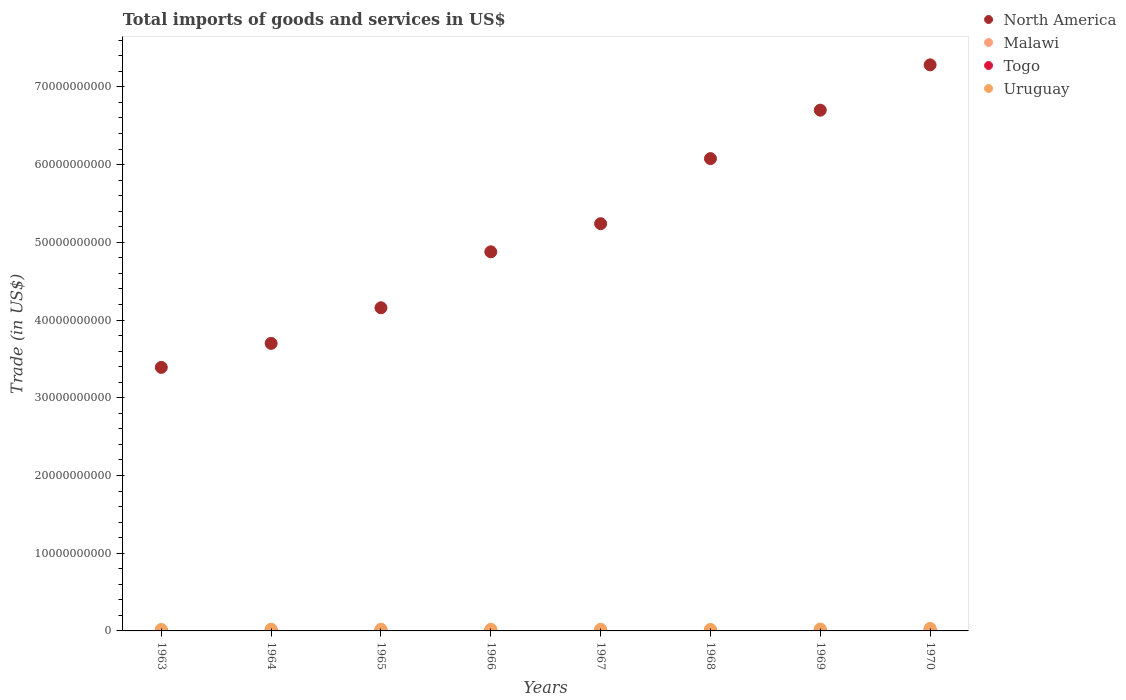How many different coloured dotlines are there?
Ensure brevity in your answer.  4. Is the number of dotlines equal to the number of legend labels?
Your answer should be compact. Yes. What is the total imports of goods and services in Malawi in 1963?
Offer a terse response. 7.15e+07. Across all years, what is the maximum total imports of goods and services in Togo?
Provide a succinct answer. 9.85e+07. Across all years, what is the minimum total imports of goods and services in Togo?
Ensure brevity in your answer.  4.27e+07. In which year was the total imports of goods and services in Togo minimum?
Offer a terse response. 1963. What is the total total imports of goods and services in Togo in the graph?
Provide a short and direct response. 5.47e+08. What is the difference between the total imports of goods and services in North America in 1964 and that in 1969?
Your response must be concise. -3.00e+1. What is the difference between the total imports of goods and services in Malawi in 1967 and the total imports of goods and services in Togo in 1970?
Keep it short and to the point. -4.34e+06. What is the average total imports of goods and services in Uruguay per year?
Give a very brief answer. 2.26e+08. In the year 1965, what is the difference between the total imports of goods and services in Uruguay and total imports of goods and services in North America?
Offer a terse response. -4.14e+1. In how many years, is the total imports of goods and services in Uruguay greater than 56000000000 US$?
Keep it short and to the point. 0. What is the ratio of the total imports of goods and services in Uruguay in 1964 to that in 1966?
Provide a short and direct response. 1.08. Is the difference between the total imports of goods and services in Uruguay in 1964 and 1969 greater than the difference between the total imports of goods and services in North America in 1964 and 1969?
Ensure brevity in your answer.  Yes. What is the difference between the highest and the second highest total imports of goods and services in Uruguay?
Provide a succinct answer. 8.19e+07. What is the difference between the highest and the lowest total imports of goods and services in Uruguay?
Offer a very short reply. 1.40e+08. In how many years, is the total imports of goods and services in Malawi greater than the average total imports of goods and services in Malawi taken over all years?
Offer a terse response. 5. Is the sum of the total imports of goods and services in North America in 1967 and 1968 greater than the maximum total imports of goods and services in Togo across all years?
Ensure brevity in your answer.  Yes. Is it the case that in every year, the sum of the total imports of goods and services in North America and total imports of goods and services in Uruguay  is greater than the sum of total imports of goods and services in Malawi and total imports of goods and services in Togo?
Make the answer very short. No. Is it the case that in every year, the sum of the total imports of goods and services in Malawi and total imports of goods and services in North America  is greater than the total imports of goods and services in Togo?
Ensure brevity in your answer.  Yes. Does the total imports of goods and services in Malawi monotonically increase over the years?
Your answer should be compact. No. Is the total imports of goods and services in North America strictly greater than the total imports of goods and services in Malawi over the years?
Ensure brevity in your answer.  Yes. What is the difference between two consecutive major ticks on the Y-axis?
Keep it short and to the point. 1.00e+1. Are the values on the major ticks of Y-axis written in scientific E-notation?
Offer a terse response. No. Where does the legend appear in the graph?
Offer a very short reply. Top right. How are the legend labels stacked?
Offer a terse response. Vertical. What is the title of the graph?
Keep it short and to the point. Total imports of goods and services in US$. What is the label or title of the X-axis?
Offer a very short reply. Years. What is the label or title of the Y-axis?
Your answer should be very brief. Trade (in US$). What is the Trade (in US$) of North America in 1963?
Your answer should be very brief. 3.39e+1. What is the Trade (in US$) in Malawi in 1963?
Provide a succinct answer. 7.15e+07. What is the Trade (in US$) of Togo in 1963?
Your answer should be compact. 4.27e+07. What is the Trade (in US$) of Uruguay in 1963?
Keep it short and to the point. 1.85e+08. What is the Trade (in US$) in North America in 1964?
Offer a terse response. 3.70e+1. What is the Trade (in US$) of Malawi in 1964?
Offer a very short reply. 5.50e+07. What is the Trade (in US$) in Togo in 1964?
Your answer should be compact. 5.91e+07. What is the Trade (in US$) of Uruguay in 1964?
Give a very brief answer. 2.24e+08. What is the Trade (in US$) of North America in 1965?
Your answer should be compact. 4.16e+1. What is the Trade (in US$) of Malawi in 1965?
Your answer should be compact. 7.63e+07. What is the Trade (in US$) of Togo in 1965?
Offer a terse response. 5.83e+07. What is the Trade (in US$) in Uruguay in 1965?
Your answer should be compact. 2.17e+08. What is the Trade (in US$) in North America in 1966?
Make the answer very short. 4.88e+1. What is the Trade (in US$) of Malawi in 1966?
Offer a very short reply. 9.72e+07. What is the Trade (in US$) in Togo in 1966?
Your response must be concise. 6.75e+07. What is the Trade (in US$) in Uruguay in 1966?
Your response must be concise. 2.08e+08. What is the Trade (in US$) in North America in 1967?
Provide a succinct answer. 5.24e+1. What is the Trade (in US$) of Malawi in 1967?
Your answer should be compact. 9.42e+07. What is the Trade (in US$) of Togo in 1967?
Make the answer very short. 6.40e+07. What is the Trade (in US$) in Uruguay in 1967?
Make the answer very short. 2.11e+08. What is the Trade (in US$) of North America in 1968?
Provide a succinct answer. 6.08e+1. What is the Trade (in US$) of Malawi in 1968?
Your answer should be compact. 9.60e+07. What is the Trade (in US$) in Togo in 1968?
Provide a short and direct response. 7.04e+07. What is the Trade (in US$) in Uruguay in 1968?
Your response must be concise. 1.95e+08. What is the Trade (in US$) of North America in 1969?
Ensure brevity in your answer.  6.70e+1. What is the Trade (in US$) of Malawi in 1969?
Provide a short and direct response. 1.05e+08. What is the Trade (in US$) of Togo in 1969?
Your answer should be very brief. 8.66e+07. What is the Trade (in US$) in Uruguay in 1969?
Give a very brief answer. 2.43e+08. What is the Trade (in US$) in North America in 1970?
Provide a short and direct response. 7.28e+1. What is the Trade (in US$) of Malawi in 1970?
Your answer should be very brief. 1.14e+08. What is the Trade (in US$) of Togo in 1970?
Your answer should be compact. 9.85e+07. What is the Trade (in US$) in Uruguay in 1970?
Give a very brief answer. 3.25e+08. Across all years, what is the maximum Trade (in US$) of North America?
Offer a terse response. 7.28e+1. Across all years, what is the maximum Trade (in US$) in Malawi?
Your response must be concise. 1.14e+08. Across all years, what is the maximum Trade (in US$) in Togo?
Your answer should be compact. 9.85e+07. Across all years, what is the maximum Trade (in US$) of Uruguay?
Your answer should be compact. 3.25e+08. Across all years, what is the minimum Trade (in US$) of North America?
Make the answer very short. 3.39e+1. Across all years, what is the minimum Trade (in US$) in Malawi?
Your response must be concise. 5.50e+07. Across all years, what is the minimum Trade (in US$) in Togo?
Your response must be concise. 4.27e+07. Across all years, what is the minimum Trade (in US$) in Uruguay?
Your response must be concise. 1.85e+08. What is the total Trade (in US$) of North America in the graph?
Your answer should be compact. 4.14e+11. What is the total Trade (in US$) in Malawi in the graph?
Offer a very short reply. 7.09e+08. What is the total Trade (in US$) in Togo in the graph?
Give a very brief answer. 5.47e+08. What is the total Trade (in US$) in Uruguay in the graph?
Your answer should be compact. 1.81e+09. What is the difference between the Trade (in US$) in North America in 1963 and that in 1964?
Ensure brevity in your answer.  -3.08e+09. What is the difference between the Trade (in US$) of Malawi in 1963 and that in 1964?
Give a very brief answer. 1.65e+07. What is the difference between the Trade (in US$) of Togo in 1963 and that in 1964?
Your response must be concise. -1.64e+07. What is the difference between the Trade (in US$) in Uruguay in 1963 and that in 1964?
Give a very brief answer. -3.91e+07. What is the difference between the Trade (in US$) of North America in 1963 and that in 1965?
Ensure brevity in your answer.  -7.67e+09. What is the difference between the Trade (in US$) of Malawi in 1963 and that in 1965?
Offer a terse response. -4.76e+06. What is the difference between the Trade (in US$) of Togo in 1963 and that in 1965?
Keep it short and to the point. -1.56e+07. What is the difference between the Trade (in US$) of Uruguay in 1963 and that in 1965?
Offer a very short reply. -3.19e+07. What is the difference between the Trade (in US$) in North America in 1963 and that in 1966?
Your answer should be very brief. -1.49e+1. What is the difference between the Trade (in US$) of Malawi in 1963 and that in 1966?
Provide a short and direct response. -2.56e+07. What is the difference between the Trade (in US$) of Togo in 1963 and that in 1966?
Provide a short and direct response. -2.48e+07. What is the difference between the Trade (in US$) of Uruguay in 1963 and that in 1966?
Offer a terse response. -2.28e+07. What is the difference between the Trade (in US$) of North America in 1963 and that in 1967?
Ensure brevity in your answer.  -1.85e+1. What is the difference between the Trade (in US$) of Malawi in 1963 and that in 1967?
Give a very brief answer. -2.26e+07. What is the difference between the Trade (in US$) in Togo in 1963 and that in 1967?
Keep it short and to the point. -2.12e+07. What is the difference between the Trade (in US$) of Uruguay in 1963 and that in 1967?
Offer a very short reply. -2.55e+07. What is the difference between the Trade (in US$) in North America in 1963 and that in 1968?
Offer a terse response. -2.69e+1. What is the difference between the Trade (in US$) in Malawi in 1963 and that in 1968?
Your answer should be very brief. -2.45e+07. What is the difference between the Trade (in US$) of Togo in 1963 and that in 1968?
Ensure brevity in your answer.  -2.77e+07. What is the difference between the Trade (in US$) in Uruguay in 1963 and that in 1968?
Offer a terse response. -9.49e+06. What is the difference between the Trade (in US$) in North America in 1963 and that in 1969?
Give a very brief answer. -3.31e+1. What is the difference between the Trade (in US$) of Malawi in 1963 and that in 1969?
Offer a terse response. -3.37e+07. What is the difference between the Trade (in US$) in Togo in 1963 and that in 1969?
Your response must be concise. -4.39e+07. What is the difference between the Trade (in US$) of Uruguay in 1963 and that in 1969?
Your answer should be compact. -5.81e+07. What is the difference between the Trade (in US$) in North America in 1963 and that in 1970?
Offer a terse response. -3.89e+1. What is the difference between the Trade (in US$) of Malawi in 1963 and that in 1970?
Ensure brevity in your answer.  -4.22e+07. What is the difference between the Trade (in US$) of Togo in 1963 and that in 1970?
Provide a short and direct response. -5.58e+07. What is the difference between the Trade (in US$) in Uruguay in 1963 and that in 1970?
Your answer should be very brief. -1.40e+08. What is the difference between the Trade (in US$) of North America in 1964 and that in 1965?
Your response must be concise. -4.58e+09. What is the difference between the Trade (in US$) of Malawi in 1964 and that in 1965?
Your response must be concise. -2.13e+07. What is the difference between the Trade (in US$) of Togo in 1964 and that in 1965?
Ensure brevity in your answer.  8.27e+05. What is the difference between the Trade (in US$) of Uruguay in 1964 and that in 1965?
Make the answer very short. 7.14e+06. What is the difference between the Trade (in US$) of North America in 1964 and that in 1966?
Ensure brevity in your answer.  -1.18e+1. What is the difference between the Trade (in US$) of Malawi in 1964 and that in 1966?
Keep it short and to the point. -4.21e+07. What is the difference between the Trade (in US$) in Togo in 1964 and that in 1966?
Provide a succinct answer. -8.39e+06. What is the difference between the Trade (in US$) in Uruguay in 1964 and that in 1966?
Your response must be concise. 1.63e+07. What is the difference between the Trade (in US$) in North America in 1964 and that in 1967?
Offer a very short reply. -1.54e+1. What is the difference between the Trade (in US$) in Malawi in 1964 and that in 1967?
Your response must be concise. -3.92e+07. What is the difference between the Trade (in US$) in Togo in 1964 and that in 1967?
Make the answer very short. -4.85e+06. What is the difference between the Trade (in US$) of Uruguay in 1964 and that in 1967?
Keep it short and to the point. 1.36e+07. What is the difference between the Trade (in US$) of North America in 1964 and that in 1968?
Your response must be concise. -2.38e+1. What is the difference between the Trade (in US$) in Malawi in 1964 and that in 1968?
Your answer should be compact. -4.10e+07. What is the difference between the Trade (in US$) of Togo in 1964 and that in 1968?
Provide a short and direct response. -1.13e+07. What is the difference between the Trade (in US$) of Uruguay in 1964 and that in 1968?
Make the answer very short. 2.96e+07. What is the difference between the Trade (in US$) of North America in 1964 and that in 1969?
Ensure brevity in your answer.  -3.00e+1. What is the difference between the Trade (in US$) of Malawi in 1964 and that in 1969?
Your answer should be very brief. -5.02e+07. What is the difference between the Trade (in US$) of Togo in 1964 and that in 1969?
Offer a terse response. -2.75e+07. What is the difference between the Trade (in US$) in Uruguay in 1964 and that in 1969?
Ensure brevity in your answer.  -1.90e+07. What is the difference between the Trade (in US$) of North America in 1964 and that in 1970?
Offer a very short reply. -3.58e+1. What is the difference between the Trade (in US$) in Malawi in 1964 and that in 1970?
Offer a very short reply. -5.87e+07. What is the difference between the Trade (in US$) of Togo in 1964 and that in 1970?
Your answer should be very brief. -3.94e+07. What is the difference between the Trade (in US$) of Uruguay in 1964 and that in 1970?
Make the answer very short. -1.01e+08. What is the difference between the Trade (in US$) of North America in 1965 and that in 1966?
Keep it short and to the point. -7.20e+09. What is the difference between the Trade (in US$) in Malawi in 1965 and that in 1966?
Your answer should be compact. -2.09e+07. What is the difference between the Trade (in US$) of Togo in 1965 and that in 1966?
Offer a very short reply. -9.21e+06. What is the difference between the Trade (in US$) of Uruguay in 1965 and that in 1966?
Your answer should be very brief. 9.15e+06. What is the difference between the Trade (in US$) of North America in 1965 and that in 1967?
Your response must be concise. -1.08e+1. What is the difference between the Trade (in US$) in Malawi in 1965 and that in 1967?
Your answer should be very brief. -1.79e+07. What is the difference between the Trade (in US$) of Togo in 1965 and that in 1967?
Your answer should be compact. -5.68e+06. What is the difference between the Trade (in US$) in Uruguay in 1965 and that in 1967?
Offer a terse response. 6.42e+06. What is the difference between the Trade (in US$) in North America in 1965 and that in 1968?
Keep it short and to the point. -1.92e+1. What is the difference between the Trade (in US$) of Malawi in 1965 and that in 1968?
Offer a terse response. -1.97e+07. What is the difference between the Trade (in US$) in Togo in 1965 and that in 1968?
Your answer should be very brief. -1.21e+07. What is the difference between the Trade (in US$) in Uruguay in 1965 and that in 1968?
Provide a succinct answer. 2.25e+07. What is the difference between the Trade (in US$) of North America in 1965 and that in 1969?
Give a very brief answer. -2.54e+1. What is the difference between the Trade (in US$) of Malawi in 1965 and that in 1969?
Your response must be concise. -2.89e+07. What is the difference between the Trade (in US$) in Togo in 1965 and that in 1969?
Your answer should be compact. -2.83e+07. What is the difference between the Trade (in US$) in Uruguay in 1965 and that in 1969?
Make the answer very short. -2.62e+07. What is the difference between the Trade (in US$) in North America in 1965 and that in 1970?
Give a very brief answer. -3.13e+1. What is the difference between the Trade (in US$) in Malawi in 1965 and that in 1970?
Ensure brevity in your answer.  -3.75e+07. What is the difference between the Trade (in US$) in Togo in 1965 and that in 1970?
Your answer should be very brief. -4.02e+07. What is the difference between the Trade (in US$) in Uruguay in 1965 and that in 1970?
Keep it short and to the point. -1.08e+08. What is the difference between the Trade (in US$) in North America in 1966 and that in 1967?
Keep it short and to the point. -3.62e+09. What is the difference between the Trade (in US$) of Malawi in 1966 and that in 1967?
Give a very brief answer. 2.99e+06. What is the difference between the Trade (in US$) of Togo in 1966 and that in 1967?
Give a very brief answer. 3.53e+06. What is the difference between the Trade (in US$) in Uruguay in 1966 and that in 1967?
Offer a terse response. -2.73e+06. What is the difference between the Trade (in US$) of North America in 1966 and that in 1968?
Offer a very short reply. -1.20e+1. What is the difference between the Trade (in US$) in Malawi in 1966 and that in 1968?
Offer a terse response. 1.16e+06. What is the difference between the Trade (in US$) in Togo in 1966 and that in 1968?
Provide a short and direct response. -2.91e+06. What is the difference between the Trade (in US$) in Uruguay in 1966 and that in 1968?
Provide a short and direct response. 1.33e+07. What is the difference between the Trade (in US$) in North America in 1966 and that in 1969?
Keep it short and to the point. -1.82e+1. What is the difference between the Trade (in US$) in Malawi in 1966 and that in 1969?
Offer a terse response. -8.08e+06. What is the difference between the Trade (in US$) of Togo in 1966 and that in 1969?
Your answer should be compact. -1.91e+07. What is the difference between the Trade (in US$) in Uruguay in 1966 and that in 1969?
Make the answer very short. -3.53e+07. What is the difference between the Trade (in US$) in North America in 1966 and that in 1970?
Your answer should be very brief. -2.41e+1. What is the difference between the Trade (in US$) of Malawi in 1966 and that in 1970?
Make the answer very short. -1.66e+07. What is the difference between the Trade (in US$) of Togo in 1966 and that in 1970?
Ensure brevity in your answer.  -3.10e+07. What is the difference between the Trade (in US$) of Uruguay in 1966 and that in 1970?
Keep it short and to the point. -1.17e+08. What is the difference between the Trade (in US$) of North America in 1967 and that in 1968?
Keep it short and to the point. -8.37e+09. What is the difference between the Trade (in US$) of Malawi in 1967 and that in 1968?
Give a very brief answer. -1.83e+06. What is the difference between the Trade (in US$) of Togo in 1967 and that in 1968?
Provide a short and direct response. -6.44e+06. What is the difference between the Trade (in US$) in Uruguay in 1967 and that in 1968?
Offer a terse response. 1.60e+07. What is the difference between the Trade (in US$) in North America in 1967 and that in 1969?
Make the answer very short. -1.46e+1. What is the difference between the Trade (in US$) in Malawi in 1967 and that in 1969?
Give a very brief answer. -1.11e+07. What is the difference between the Trade (in US$) of Togo in 1967 and that in 1969?
Provide a short and direct response. -2.26e+07. What is the difference between the Trade (in US$) in Uruguay in 1967 and that in 1969?
Make the answer very short. -3.26e+07. What is the difference between the Trade (in US$) of North America in 1967 and that in 1970?
Give a very brief answer. -2.04e+1. What is the difference between the Trade (in US$) in Malawi in 1967 and that in 1970?
Offer a very short reply. -1.96e+07. What is the difference between the Trade (in US$) in Togo in 1967 and that in 1970?
Your answer should be compact. -3.46e+07. What is the difference between the Trade (in US$) in Uruguay in 1967 and that in 1970?
Offer a very short reply. -1.14e+08. What is the difference between the Trade (in US$) of North America in 1968 and that in 1969?
Your answer should be very brief. -6.23e+09. What is the difference between the Trade (in US$) of Malawi in 1968 and that in 1969?
Provide a succinct answer. -9.24e+06. What is the difference between the Trade (in US$) of Togo in 1968 and that in 1969?
Ensure brevity in your answer.  -1.62e+07. What is the difference between the Trade (in US$) of Uruguay in 1968 and that in 1969?
Offer a very short reply. -4.86e+07. What is the difference between the Trade (in US$) of North America in 1968 and that in 1970?
Ensure brevity in your answer.  -1.21e+1. What is the difference between the Trade (in US$) of Malawi in 1968 and that in 1970?
Provide a succinct answer. -1.78e+07. What is the difference between the Trade (in US$) of Togo in 1968 and that in 1970?
Offer a very short reply. -2.81e+07. What is the difference between the Trade (in US$) of Uruguay in 1968 and that in 1970?
Offer a terse response. -1.30e+08. What is the difference between the Trade (in US$) in North America in 1969 and that in 1970?
Keep it short and to the point. -5.83e+09. What is the difference between the Trade (in US$) of Malawi in 1969 and that in 1970?
Your response must be concise. -8.52e+06. What is the difference between the Trade (in US$) of Togo in 1969 and that in 1970?
Ensure brevity in your answer.  -1.19e+07. What is the difference between the Trade (in US$) in Uruguay in 1969 and that in 1970?
Give a very brief answer. -8.19e+07. What is the difference between the Trade (in US$) in North America in 1963 and the Trade (in US$) in Malawi in 1964?
Ensure brevity in your answer.  3.39e+1. What is the difference between the Trade (in US$) in North America in 1963 and the Trade (in US$) in Togo in 1964?
Provide a short and direct response. 3.38e+1. What is the difference between the Trade (in US$) in North America in 1963 and the Trade (in US$) in Uruguay in 1964?
Provide a short and direct response. 3.37e+1. What is the difference between the Trade (in US$) of Malawi in 1963 and the Trade (in US$) of Togo in 1964?
Offer a terse response. 1.24e+07. What is the difference between the Trade (in US$) of Malawi in 1963 and the Trade (in US$) of Uruguay in 1964?
Offer a terse response. -1.53e+08. What is the difference between the Trade (in US$) in Togo in 1963 and the Trade (in US$) in Uruguay in 1964?
Keep it short and to the point. -1.81e+08. What is the difference between the Trade (in US$) in North America in 1963 and the Trade (in US$) in Malawi in 1965?
Keep it short and to the point. 3.38e+1. What is the difference between the Trade (in US$) of North America in 1963 and the Trade (in US$) of Togo in 1965?
Give a very brief answer. 3.39e+1. What is the difference between the Trade (in US$) of North America in 1963 and the Trade (in US$) of Uruguay in 1965?
Your answer should be very brief. 3.37e+1. What is the difference between the Trade (in US$) in Malawi in 1963 and the Trade (in US$) in Togo in 1965?
Make the answer very short. 1.33e+07. What is the difference between the Trade (in US$) of Malawi in 1963 and the Trade (in US$) of Uruguay in 1965?
Provide a succinct answer. -1.45e+08. What is the difference between the Trade (in US$) of Togo in 1963 and the Trade (in US$) of Uruguay in 1965?
Your response must be concise. -1.74e+08. What is the difference between the Trade (in US$) of North America in 1963 and the Trade (in US$) of Malawi in 1966?
Your answer should be compact. 3.38e+1. What is the difference between the Trade (in US$) in North America in 1963 and the Trade (in US$) in Togo in 1966?
Keep it short and to the point. 3.38e+1. What is the difference between the Trade (in US$) in North America in 1963 and the Trade (in US$) in Uruguay in 1966?
Ensure brevity in your answer.  3.37e+1. What is the difference between the Trade (in US$) of Malawi in 1963 and the Trade (in US$) of Togo in 1966?
Offer a very short reply. 4.05e+06. What is the difference between the Trade (in US$) of Malawi in 1963 and the Trade (in US$) of Uruguay in 1966?
Provide a short and direct response. -1.36e+08. What is the difference between the Trade (in US$) of Togo in 1963 and the Trade (in US$) of Uruguay in 1966?
Your answer should be very brief. -1.65e+08. What is the difference between the Trade (in US$) in North America in 1963 and the Trade (in US$) in Malawi in 1967?
Ensure brevity in your answer.  3.38e+1. What is the difference between the Trade (in US$) of North America in 1963 and the Trade (in US$) of Togo in 1967?
Ensure brevity in your answer.  3.38e+1. What is the difference between the Trade (in US$) in North America in 1963 and the Trade (in US$) in Uruguay in 1967?
Your answer should be compact. 3.37e+1. What is the difference between the Trade (in US$) of Malawi in 1963 and the Trade (in US$) of Togo in 1967?
Offer a terse response. 7.59e+06. What is the difference between the Trade (in US$) of Malawi in 1963 and the Trade (in US$) of Uruguay in 1967?
Your answer should be compact. -1.39e+08. What is the difference between the Trade (in US$) in Togo in 1963 and the Trade (in US$) in Uruguay in 1967?
Your response must be concise. -1.68e+08. What is the difference between the Trade (in US$) in North America in 1963 and the Trade (in US$) in Malawi in 1968?
Provide a succinct answer. 3.38e+1. What is the difference between the Trade (in US$) in North America in 1963 and the Trade (in US$) in Togo in 1968?
Keep it short and to the point. 3.38e+1. What is the difference between the Trade (in US$) of North America in 1963 and the Trade (in US$) of Uruguay in 1968?
Provide a short and direct response. 3.37e+1. What is the difference between the Trade (in US$) of Malawi in 1963 and the Trade (in US$) of Togo in 1968?
Ensure brevity in your answer.  1.15e+06. What is the difference between the Trade (in US$) in Malawi in 1963 and the Trade (in US$) in Uruguay in 1968?
Your response must be concise. -1.23e+08. What is the difference between the Trade (in US$) of Togo in 1963 and the Trade (in US$) of Uruguay in 1968?
Your answer should be compact. -1.52e+08. What is the difference between the Trade (in US$) in North America in 1963 and the Trade (in US$) in Malawi in 1969?
Keep it short and to the point. 3.38e+1. What is the difference between the Trade (in US$) in North America in 1963 and the Trade (in US$) in Togo in 1969?
Provide a short and direct response. 3.38e+1. What is the difference between the Trade (in US$) of North America in 1963 and the Trade (in US$) of Uruguay in 1969?
Your answer should be compact. 3.37e+1. What is the difference between the Trade (in US$) of Malawi in 1963 and the Trade (in US$) of Togo in 1969?
Your answer should be very brief. -1.50e+07. What is the difference between the Trade (in US$) of Malawi in 1963 and the Trade (in US$) of Uruguay in 1969?
Ensure brevity in your answer.  -1.72e+08. What is the difference between the Trade (in US$) in Togo in 1963 and the Trade (in US$) in Uruguay in 1969?
Your answer should be very brief. -2.00e+08. What is the difference between the Trade (in US$) of North America in 1963 and the Trade (in US$) of Malawi in 1970?
Offer a terse response. 3.38e+1. What is the difference between the Trade (in US$) of North America in 1963 and the Trade (in US$) of Togo in 1970?
Provide a short and direct response. 3.38e+1. What is the difference between the Trade (in US$) in North America in 1963 and the Trade (in US$) in Uruguay in 1970?
Provide a short and direct response. 3.36e+1. What is the difference between the Trade (in US$) in Malawi in 1963 and the Trade (in US$) in Togo in 1970?
Provide a short and direct response. -2.70e+07. What is the difference between the Trade (in US$) of Malawi in 1963 and the Trade (in US$) of Uruguay in 1970?
Your answer should be very brief. -2.53e+08. What is the difference between the Trade (in US$) in Togo in 1963 and the Trade (in US$) in Uruguay in 1970?
Your response must be concise. -2.82e+08. What is the difference between the Trade (in US$) of North America in 1964 and the Trade (in US$) of Malawi in 1965?
Your answer should be very brief. 3.69e+1. What is the difference between the Trade (in US$) in North America in 1964 and the Trade (in US$) in Togo in 1965?
Offer a terse response. 3.69e+1. What is the difference between the Trade (in US$) in North America in 1964 and the Trade (in US$) in Uruguay in 1965?
Provide a short and direct response. 3.68e+1. What is the difference between the Trade (in US$) in Malawi in 1964 and the Trade (in US$) in Togo in 1965?
Your answer should be compact. -3.25e+06. What is the difference between the Trade (in US$) in Malawi in 1964 and the Trade (in US$) in Uruguay in 1965?
Give a very brief answer. -1.62e+08. What is the difference between the Trade (in US$) of Togo in 1964 and the Trade (in US$) of Uruguay in 1965?
Keep it short and to the point. -1.58e+08. What is the difference between the Trade (in US$) in North America in 1964 and the Trade (in US$) in Malawi in 1966?
Provide a succinct answer. 3.69e+1. What is the difference between the Trade (in US$) in North America in 1964 and the Trade (in US$) in Togo in 1966?
Provide a short and direct response. 3.69e+1. What is the difference between the Trade (in US$) of North America in 1964 and the Trade (in US$) of Uruguay in 1966?
Make the answer very short. 3.68e+1. What is the difference between the Trade (in US$) of Malawi in 1964 and the Trade (in US$) of Togo in 1966?
Offer a terse response. -1.25e+07. What is the difference between the Trade (in US$) of Malawi in 1964 and the Trade (in US$) of Uruguay in 1966?
Your response must be concise. -1.53e+08. What is the difference between the Trade (in US$) in Togo in 1964 and the Trade (in US$) in Uruguay in 1966?
Give a very brief answer. -1.49e+08. What is the difference between the Trade (in US$) of North America in 1964 and the Trade (in US$) of Malawi in 1967?
Provide a succinct answer. 3.69e+1. What is the difference between the Trade (in US$) in North America in 1964 and the Trade (in US$) in Togo in 1967?
Ensure brevity in your answer.  3.69e+1. What is the difference between the Trade (in US$) of North America in 1964 and the Trade (in US$) of Uruguay in 1967?
Give a very brief answer. 3.68e+1. What is the difference between the Trade (in US$) in Malawi in 1964 and the Trade (in US$) in Togo in 1967?
Your answer should be compact. -8.93e+06. What is the difference between the Trade (in US$) of Malawi in 1964 and the Trade (in US$) of Uruguay in 1967?
Your answer should be compact. -1.56e+08. What is the difference between the Trade (in US$) in Togo in 1964 and the Trade (in US$) in Uruguay in 1967?
Offer a very short reply. -1.51e+08. What is the difference between the Trade (in US$) of North America in 1964 and the Trade (in US$) of Malawi in 1968?
Keep it short and to the point. 3.69e+1. What is the difference between the Trade (in US$) of North America in 1964 and the Trade (in US$) of Togo in 1968?
Offer a terse response. 3.69e+1. What is the difference between the Trade (in US$) of North America in 1964 and the Trade (in US$) of Uruguay in 1968?
Your response must be concise. 3.68e+1. What is the difference between the Trade (in US$) in Malawi in 1964 and the Trade (in US$) in Togo in 1968?
Give a very brief answer. -1.54e+07. What is the difference between the Trade (in US$) of Malawi in 1964 and the Trade (in US$) of Uruguay in 1968?
Offer a very short reply. -1.39e+08. What is the difference between the Trade (in US$) in Togo in 1964 and the Trade (in US$) in Uruguay in 1968?
Offer a very short reply. -1.35e+08. What is the difference between the Trade (in US$) in North America in 1964 and the Trade (in US$) in Malawi in 1969?
Offer a terse response. 3.69e+1. What is the difference between the Trade (in US$) of North America in 1964 and the Trade (in US$) of Togo in 1969?
Provide a succinct answer. 3.69e+1. What is the difference between the Trade (in US$) in North America in 1964 and the Trade (in US$) in Uruguay in 1969?
Provide a succinct answer. 3.67e+1. What is the difference between the Trade (in US$) in Malawi in 1964 and the Trade (in US$) in Togo in 1969?
Your answer should be compact. -3.16e+07. What is the difference between the Trade (in US$) in Malawi in 1964 and the Trade (in US$) in Uruguay in 1969?
Your answer should be very brief. -1.88e+08. What is the difference between the Trade (in US$) of Togo in 1964 and the Trade (in US$) of Uruguay in 1969?
Keep it short and to the point. -1.84e+08. What is the difference between the Trade (in US$) of North America in 1964 and the Trade (in US$) of Malawi in 1970?
Keep it short and to the point. 3.69e+1. What is the difference between the Trade (in US$) of North America in 1964 and the Trade (in US$) of Togo in 1970?
Offer a very short reply. 3.69e+1. What is the difference between the Trade (in US$) of North America in 1964 and the Trade (in US$) of Uruguay in 1970?
Make the answer very short. 3.67e+1. What is the difference between the Trade (in US$) of Malawi in 1964 and the Trade (in US$) of Togo in 1970?
Provide a short and direct response. -4.35e+07. What is the difference between the Trade (in US$) of Malawi in 1964 and the Trade (in US$) of Uruguay in 1970?
Provide a short and direct response. -2.70e+08. What is the difference between the Trade (in US$) of Togo in 1964 and the Trade (in US$) of Uruguay in 1970?
Offer a very short reply. -2.66e+08. What is the difference between the Trade (in US$) in North America in 1965 and the Trade (in US$) in Malawi in 1966?
Provide a short and direct response. 4.15e+1. What is the difference between the Trade (in US$) of North America in 1965 and the Trade (in US$) of Togo in 1966?
Provide a succinct answer. 4.15e+1. What is the difference between the Trade (in US$) in North America in 1965 and the Trade (in US$) in Uruguay in 1966?
Your response must be concise. 4.14e+1. What is the difference between the Trade (in US$) in Malawi in 1965 and the Trade (in US$) in Togo in 1966?
Make the answer very short. 8.81e+06. What is the difference between the Trade (in US$) in Malawi in 1965 and the Trade (in US$) in Uruguay in 1966?
Offer a very short reply. -1.32e+08. What is the difference between the Trade (in US$) in Togo in 1965 and the Trade (in US$) in Uruguay in 1966?
Ensure brevity in your answer.  -1.50e+08. What is the difference between the Trade (in US$) in North America in 1965 and the Trade (in US$) in Malawi in 1967?
Provide a succinct answer. 4.15e+1. What is the difference between the Trade (in US$) of North America in 1965 and the Trade (in US$) of Togo in 1967?
Your answer should be very brief. 4.15e+1. What is the difference between the Trade (in US$) of North America in 1965 and the Trade (in US$) of Uruguay in 1967?
Provide a short and direct response. 4.14e+1. What is the difference between the Trade (in US$) of Malawi in 1965 and the Trade (in US$) of Togo in 1967?
Ensure brevity in your answer.  1.23e+07. What is the difference between the Trade (in US$) of Malawi in 1965 and the Trade (in US$) of Uruguay in 1967?
Provide a succinct answer. -1.34e+08. What is the difference between the Trade (in US$) in Togo in 1965 and the Trade (in US$) in Uruguay in 1967?
Offer a very short reply. -1.52e+08. What is the difference between the Trade (in US$) in North America in 1965 and the Trade (in US$) in Malawi in 1968?
Your answer should be compact. 4.15e+1. What is the difference between the Trade (in US$) in North America in 1965 and the Trade (in US$) in Togo in 1968?
Keep it short and to the point. 4.15e+1. What is the difference between the Trade (in US$) in North America in 1965 and the Trade (in US$) in Uruguay in 1968?
Your answer should be compact. 4.14e+1. What is the difference between the Trade (in US$) of Malawi in 1965 and the Trade (in US$) of Togo in 1968?
Give a very brief answer. 5.91e+06. What is the difference between the Trade (in US$) in Malawi in 1965 and the Trade (in US$) in Uruguay in 1968?
Make the answer very short. -1.18e+08. What is the difference between the Trade (in US$) in Togo in 1965 and the Trade (in US$) in Uruguay in 1968?
Provide a short and direct response. -1.36e+08. What is the difference between the Trade (in US$) of North America in 1965 and the Trade (in US$) of Malawi in 1969?
Your answer should be compact. 4.15e+1. What is the difference between the Trade (in US$) of North America in 1965 and the Trade (in US$) of Togo in 1969?
Provide a short and direct response. 4.15e+1. What is the difference between the Trade (in US$) of North America in 1965 and the Trade (in US$) of Uruguay in 1969?
Keep it short and to the point. 4.13e+1. What is the difference between the Trade (in US$) of Malawi in 1965 and the Trade (in US$) of Togo in 1969?
Provide a succinct answer. -1.03e+07. What is the difference between the Trade (in US$) of Malawi in 1965 and the Trade (in US$) of Uruguay in 1969?
Make the answer very short. -1.67e+08. What is the difference between the Trade (in US$) in Togo in 1965 and the Trade (in US$) in Uruguay in 1969?
Provide a short and direct response. -1.85e+08. What is the difference between the Trade (in US$) of North America in 1965 and the Trade (in US$) of Malawi in 1970?
Your answer should be compact. 4.15e+1. What is the difference between the Trade (in US$) in North America in 1965 and the Trade (in US$) in Togo in 1970?
Keep it short and to the point. 4.15e+1. What is the difference between the Trade (in US$) of North America in 1965 and the Trade (in US$) of Uruguay in 1970?
Make the answer very short. 4.13e+1. What is the difference between the Trade (in US$) in Malawi in 1965 and the Trade (in US$) in Togo in 1970?
Ensure brevity in your answer.  -2.22e+07. What is the difference between the Trade (in US$) in Malawi in 1965 and the Trade (in US$) in Uruguay in 1970?
Keep it short and to the point. -2.49e+08. What is the difference between the Trade (in US$) of Togo in 1965 and the Trade (in US$) of Uruguay in 1970?
Your answer should be very brief. -2.67e+08. What is the difference between the Trade (in US$) of North America in 1966 and the Trade (in US$) of Malawi in 1967?
Provide a short and direct response. 4.87e+1. What is the difference between the Trade (in US$) in North America in 1966 and the Trade (in US$) in Togo in 1967?
Provide a short and direct response. 4.87e+1. What is the difference between the Trade (in US$) in North America in 1966 and the Trade (in US$) in Uruguay in 1967?
Ensure brevity in your answer.  4.86e+1. What is the difference between the Trade (in US$) in Malawi in 1966 and the Trade (in US$) in Togo in 1967?
Ensure brevity in your answer.  3.32e+07. What is the difference between the Trade (in US$) of Malawi in 1966 and the Trade (in US$) of Uruguay in 1967?
Your answer should be compact. -1.13e+08. What is the difference between the Trade (in US$) of Togo in 1966 and the Trade (in US$) of Uruguay in 1967?
Keep it short and to the point. -1.43e+08. What is the difference between the Trade (in US$) of North America in 1966 and the Trade (in US$) of Malawi in 1968?
Provide a short and direct response. 4.87e+1. What is the difference between the Trade (in US$) in North America in 1966 and the Trade (in US$) in Togo in 1968?
Give a very brief answer. 4.87e+1. What is the difference between the Trade (in US$) of North America in 1966 and the Trade (in US$) of Uruguay in 1968?
Provide a short and direct response. 4.86e+1. What is the difference between the Trade (in US$) of Malawi in 1966 and the Trade (in US$) of Togo in 1968?
Make the answer very short. 2.68e+07. What is the difference between the Trade (in US$) in Malawi in 1966 and the Trade (in US$) in Uruguay in 1968?
Keep it short and to the point. -9.74e+07. What is the difference between the Trade (in US$) in Togo in 1966 and the Trade (in US$) in Uruguay in 1968?
Provide a succinct answer. -1.27e+08. What is the difference between the Trade (in US$) in North America in 1966 and the Trade (in US$) in Malawi in 1969?
Offer a terse response. 4.87e+1. What is the difference between the Trade (in US$) of North America in 1966 and the Trade (in US$) of Togo in 1969?
Provide a short and direct response. 4.87e+1. What is the difference between the Trade (in US$) of North America in 1966 and the Trade (in US$) of Uruguay in 1969?
Your answer should be compact. 4.85e+1. What is the difference between the Trade (in US$) in Malawi in 1966 and the Trade (in US$) in Togo in 1969?
Provide a short and direct response. 1.06e+07. What is the difference between the Trade (in US$) in Malawi in 1966 and the Trade (in US$) in Uruguay in 1969?
Offer a very short reply. -1.46e+08. What is the difference between the Trade (in US$) in Togo in 1966 and the Trade (in US$) in Uruguay in 1969?
Offer a very short reply. -1.76e+08. What is the difference between the Trade (in US$) of North America in 1966 and the Trade (in US$) of Malawi in 1970?
Make the answer very short. 4.87e+1. What is the difference between the Trade (in US$) in North America in 1966 and the Trade (in US$) in Togo in 1970?
Provide a short and direct response. 4.87e+1. What is the difference between the Trade (in US$) of North America in 1966 and the Trade (in US$) of Uruguay in 1970?
Offer a very short reply. 4.85e+1. What is the difference between the Trade (in US$) in Malawi in 1966 and the Trade (in US$) in Togo in 1970?
Keep it short and to the point. -1.35e+06. What is the difference between the Trade (in US$) in Malawi in 1966 and the Trade (in US$) in Uruguay in 1970?
Offer a terse response. -2.28e+08. What is the difference between the Trade (in US$) of Togo in 1966 and the Trade (in US$) of Uruguay in 1970?
Give a very brief answer. -2.58e+08. What is the difference between the Trade (in US$) of North America in 1967 and the Trade (in US$) of Malawi in 1968?
Offer a very short reply. 5.23e+1. What is the difference between the Trade (in US$) of North America in 1967 and the Trade (in US$) of Togo in 1968?
Ensure brevity in your answer.  5.23e+1. What is the difference between the Trade (in US$) of North America in 1967 and the Trade (in US$) of Uruguay in 1968?
Your answer should be very brief. 5.22e+1. What is the difference between the Trade (in US$) of Malawi in 1967 and the Trade (in US$) of Togo in 1968?
Your answer should be compact. 2.38e+07. What is the difference between the Trade (in US$) in Malawi in 1967 and the Trade (in US$) in Uruguay in 1968?
Make the answer very short. -1.00e+08. What is the difference between the Trade (in US$) of Togo in 1967 and the Trade (in US$) of Uruguay in 1968?
Offer a very short reply. -1.31e+08. What is the difference between the Trade (in US$) of North America in 1967 and the Trade (in US$) of Malawi in 1969?
Ensure brevity in your answer.  5.23e+1. What is the difference between the Trade (in US$) in North America in 1967 and the Trade (in US$) in Togo in 1969?
Provide a short and direct response. 5.23e+1. What is the difference between the Trade (in US$) in North America in 1967 and the Trade (in US$) in Uruguay in 1969?
Provide a succinct answer. 5.22e+1. What is the difference between the Trade (in US$) in Malawi in 1967 and the Trade (in US$) in Togo in 1969?
Keep it short and to the point. 7.58e+06. What is the difference between the Trade (in US$) of Malawi in 1967 and the Trade (in US$) of Uruguay in 1969?
Your answer should be compact. -1.49e+08. What is the difference between the Trade (in US$) of Togo in 1967 and the Trade (in US$) of Uruguay in 1969?
Give a very brief answer. -1.79e+08. What is the difference between the Trade (in US$) in North America in 1967 and the Trade (in US$) in Malawi in 1970?
Provide a succinct answer. 5.23e+1. What is the difference between the Trade (in US$) in North America in 1967 and the Trade (in US$) in Togo in 1970?
Your response must be concise. 5.23e+1. What is the difference between the Trade (in US$) of North America in 1967 and the Trade (in US$) of Uruguay in 1970?
Your answer should be very brief. 5.21e+1. What is the difference between the Trade (in US$) of Malawi in 1967 and the Trade (in US$) of Togo in 1970?
Your answer should be very brief. -4.34e+06. What is the difference between the Trade (in US$) in Malawi in 1967 and the Trade (in US$) in Uruguay in 1970?
Provide a short and direct response. -2.31e+08. What is the difference between the Trade (in US$) of Togo in 1967 and the Trade (in US$) of Uruguay in 1970?
Give a very brief answer. -2.61e+08. What is the difference between the Trade (in US$) of North America in 1968 and the Trade (in US$) of Malawi in 1969?
Offer a very short reply. 6.07e+1. What is the difference between the Trade (in US$) of North America in 1968 and the Trade (in US$) of Togo in 1969?
Your answer should be compact. 6.07e+1. What is the difference between the Trade (in US$) of North America in 1968 and the Trade (in US$) of Uruguay in 1969?
Offer a terse response. 6.05e+1. What is the difference between the Trade (in US$) of Malawi in 1968 and the Trade (in US$) of Togo in 1969?
Your response must be concise. 9.41e+06. What is the difference between the Trade (in US$) in Malawi in 1968 and the Trade (in US$) in Uruguay in 1969?
Your response must be concise. -1.47e+08. What is the difference between the Trade (in US$) in Togo in 1968 and the Trade (in US$) in Uruguay in 1969?
Offer a terse response. -1.73e+08. What is the difference between the Trade (in US$) of North America in 1968 and the Trade (in US$) of Malawi in 1970?
Your answer should be compact. 6.07e+1. What is the difference between the Trade (in US$) of North America in 1968 and the Trade (in US$) of Togo in 1970?
Offer a terse response. 6.07e+1. What is the difference between the Trade (in US$) of North America in 1968 and the Trade (in US$) of Uruguay in 1970?
Your answer should be compact. 6.04e+1. What is the difference between the Trade (in US$) in Malawi in 1968 and the Trade (in US$) in Togo in 1970?
Your answer should be very brief. -2.51e+06. What is the difference between the Trade (in US$) of Malawi in 1968 and the Trade (in US$) of Uruguay in 1970?
Keep it short and to the point. -2.29e+08. What is the difference between the Trade (in US$) in Togo in 1968 and the Trade (in US$) in Uruguay in 1970?
Give a very brief answer. -2.55e+08. What is the difference between the Trade (in US$) of North America in 1969 and the Trade (in US$) of Malawi in 1970?
Keep it short and to the point. 6.69e+1. What is the difference between the Trade (in US$) in North America in 1969 and the Trade (in US$) in Togo in 1970?
Your response must be concise. 6.69e+1. What is the difference between the Trade (in US$) of North America in 1969 and the Trade (in US$) of Uruguay in 1970?
Keep it short and to the point. 6.67e+1. What is the difference between the Trade (in US$) in Malawi in 1969 and the Trade (in US$) in Togo in 1970?
Keep it short and to the point. 6.73e+06. What is the difference between the Trade (in US$) of Malawi in 1969 and the Trade (in US$) of Uruguay in 1970?
Keep it short and to the point. -2.20e+08. What is the difference between the Trade (in US$) in Togo in 1969 and the Trade (in US$) in Uruguay in 1970?
Offer a very short reply. -2.38e+08. What is the average Trade (in US$) in North America per year?
Give a very brief answer. 5.18e+1. What is the average Trade (in US$) in Malawi per year?
Your response must be concise. 8.86e+07. What is the average Trade (in US$) of Togo per year?
Your response must be concise. 6.84e+07. What is the average Trade (in US$) of Uruguay per year?
Make the answer very short. 2.26e+08. In the year 1963, what is the difference between the Trade (in US$) of North America and Trade (in US$) of Malawi?
Provide a succinct answer. 3.38e+1. In the year 1963, what is the difference between the Trade (in US$) in North America and Trade (in US$) in Togo?
Provide a succinct answer. 3.39e+1. In the year 1963, what is the difference between the Trade (in US$) of North America and Trade (in US$) of Uruguay?
Ensure brevity in your answer.  3.37e+1. In the year 1963, what is the difference between the Trade (in US$) in Malawi and Trade (in US$) in Togo?
Provide a succinct answer. 2.88e+07. In the year 1963, what is the difference between the Trade (in US$) of Malawi and Trade (in US$) of Uruguay?
Give a very brief answer. -1.13e+08. In the year 1963, what is the difference between the Trade (in US$) in Togo and Trade (in US$) in Uruguay?
Ensure brevity in your answer.  -1.42e+08. In the year 1964, what is the difference between the Trade (in US$) in North America and Trade (in US$) in Malawi?
Give a very brief answer. 3.69e+1. In the year 1964, what is the difference between the Trade (in US$) in North America and Trade (in US$) in Togo?
Make the answer very short. 3.69e+1. In the year 1964, what is the difference between the Trade (in US$) in North America and Trade (in US$) in Uruguay?
Your answer should be very brief. 3.68e+1. In the year 1964, what is the difference between the Trade (in US$) of Malawi and Trade (in US$) of Togo?
Make the answer very short. -4.08e+06. In the year 1964, what is the difference between the Trade (in US$) in Malawi and Trade (in US$) in Uruguay?
Provide a short and direct response. -1.69e+08. In the year 1964, what is the difference between the Trade (in US$) of Togo and Trade (in US$) of Uruguay?
Offer a terse response. -1.65e+08. In the year 1965, what is the difference between the Trade (in US$) of North America and Trade (in US$) of Malawi?
Keep it short and to the point. 4.15e+1. In the year 1965, what is the difference between the Trade (in US$) in North America and Trade (in US$) in Togo?
Ensure brevity in your answer.  4.15e+1. In the year 1965, what is the difference between the Trade (in US$) in North America and Trade (in US$) in Uruguay?
Ensure brevity in your answer.  4.14e+1. In the year 1965, what is the difference between the Trade (in US$) in Malawi and Trade (in US$) in Togo?
Your answer should be very brief. 1.80e+07. In the year 1965, what is the difference between the Trade (in US$) in Malawi and Trade (in US$) in Uruguay?
Provide a short and direct response. -1.41e+08. In the year 1965, what is the difference between the Trade (in US$) in Togo and Trade (in US$) in Uruguay?
Your answer should be very brief. -1.59e+08. In the year 1966, what is the difference between the Trade (in US$) of North America and Trade (in US$) of Malawi?
Ensure brevity in your answer.  4.87e+1. In the year 1966, what is the difference between the Trade (in US$) in North America and Trade (in US$) in Togo?
Your response must be concise. 4.87e+1. In the year 1966, what is the difference between the Trade (in US$) of North America and Trade (in US$) of Uruguay?
Provide a short and direct response. 4.86e+1. In the year 1966, what is the difference between the Trade (in US$) in Malawi and Trade (in US$) in Togo?
Keep it short and to the point. 2.97e+07. In the year 1966, what is the difference between the Trade (in US$) in Malawi and Trade (in US$) in Uruguay?
Offer a very short reply. -1.11e+08. In the year 1966, what is the difference between the Trade (in US$) of Togo and Trade (in US$) of Uruguay?
Provide a short and direct response. -1.40e+08. In the year 1967, what is the difference between the Trade (in US$) in North America and Trade (in US$) in Malawi?
Make the answer very short. 5.23e+1. In the year 1967, what is the difference between the Trade (in US$) in North America and Trade (in US$) in Togo?
Make the answer very short. 5.23e+1. In the year 1967, what is the difference between the Trade (in US$) in North America and Trade (in US$) in Uruguay?
Make the answer very short. 5.22e+1. In the year 1967, what is the difference between the Trade (in US$) in Malawi and Trade (in US$) in Togo?
Offer a terse response. 3.02e+07. In the year 1967, what is the difference between the Trade (in US$) of Malawi and Trade (in US$) of Uruguay?
Offer a very short reply. -1.16e+08. In the year 1967, what is the difference between the Trade (in US$) of Togo and Trade (in US$) of Uruguay?
Your response must be concise. -1.47e+08. In the year 1968, what is the difference between the Trade (in US$) of North America and Trade (in US$) of Malawi?
Your answer should be compact. 6.07e+1. In the year 1968, what is the difference between the Trade (in US$) of North America and Trade (in US$) of Togo?
Ensure brevity in your answer.  6.07e+1. In the year 1968, what is the difference between the Trade (in US$) in North America and Trade (in US$) in Uruguay?
Make the answer very short. 6.06e+1. In the year 1968, what is the difference between the Trade (in US$) in Malawi and Trade (in US$) in Togo?
Your response must be concise. 2.56e+07. In the year 1968, what is the difference between the Trade (in US$) in Malawi and Trade (in US$) in Uruguay?
Ensure brevity in your answer.  -9.85e+07. In the year 1968, what is the difference between the Trade (in US$) in Togo and Trade (in US$) in Uruguay?
Ensure brevity in your answer.  -1.24e+08. In the year 1969, what is the difference between the Trade (in US$) of North America and Trade (in US$) of Malawi?
Offer a very short reply. 6.69e+1. In the year 1969, what is the difference between the Trade (in US$) in North America and Trade (in US$) in Togo?
Your response must be concise. 6.69e+1. In the year 1969, what is the difference between the Trade (in US$) in North America and Trade (in US$) in Uruguay?
Offer a very short reply. 6.68e+1. In the year 1969, what is the difference between the Trade (in US$) in Malawi and Trade (in US$) in Togo?
Make the answer very short. 1.87e+07. In the year 1969, what is the difference between the Trade (in US$) in Malawi and Trade (in US$) in Uruguay?
Offer a terse response. -1.38e+08. In the year 1969, what is the difference between the Trade (in US$) in Togo and Trade (in US$) in Uruguay?
Your response must be concise. -1.57e+08. In the year 1970, what is the difference between the Trade (in US$) in North America and Trade (in US$) in Malawi?
Keep it short and to the point. 7.27e+1. In the year 1970, what is the difference between the Trade (in US$) in North America and Trade (in US$) in Togo?
Your answer should be compact. 7.27e+1. In the year 1970, what is the difference between the Trade (in US$) of North America and Trade (in US$) of Uruguay?
Provide a succinct answer. 7.25e+1. In the year 1970, what is the difference between the Trade (in US$) of Malawi and Trade (in US$) of Togo?
Offer a terse response. 1.52e+07. In the year 1970, what is the difference between the Trade (in US$) in Malawi and Trade (in US$) in Uruguay?
Your answer should be very brief. -2.11e+08. In the year 1970, what is the difference between the Trade (in US$) in Togo and Trade (in US$) in Uruguay?
Your response must be concise. -2.26e+08. What is the ratio of the Trade (in US$) in North America in 1963 to that in 1964?
Give a very brief answer. 0.92. What is the ratio of the Trade (in US$) of Malawi in 1963 to that in 1964?
Offer a terse response. 1.3. What is the ratio of the Trade (in US$) in Togo in 1963 to that in 1964?
Provide a succinct answer. 0.72. What is the ratio of the Trade (in US$) of Uruguay in 1963 to that in 1964?
Give a very brief answer. 0.83. What is the ratio of the Trade (in US$) in North America in 1963 to that in 1965?
Your answer should be compact. 0.82. What is the ratio of the Trade (in US$) in Malawi in 1963 to that in 1965?
Your response must be concise. 0.94. What is the ratio of the Trade (in US$) of Togo in 1963 to that in 1965?
Your response must be concise. 0.73. What is the ratio of the Trade (in US$) in Uruguay in 1963 to that in 1965?
Keep it short and to the point. 0.85. What is the ratio of the Trade (in US$) in North America in 1963 to that in 1966?
Offer a very short reply. 0.7. What is the ratio of the Trade (in US$) in Malawi in 1963 to that in 1966?
Provide a succinct answer. 0.74. What is the ratio of the Trade (in US$) in Togo in 1963 to that in 1966?
Offer a terse response. 0.63. What is the ratio of the Trade (in US$) of Uruguay in 1963 to that in 1966?
Provide a succinct answer. 0.89. What is the ratio of the Trade (in US$) in North America in 1963 to that in 1967?
Your answer should be compact. 0.65. What is the ratio of the Trade (in US$) in Malawi in 1963 to that in 1967?
Keep it short and to the point. 0.76. What is the ratio of the Trade (in US$) of Togo in 1963 to that in 1967?
Give a very brief answer. 0.67. What is the ratio of the Trade (in US$) of Uruguay in 1963 to that in 1967?
Provide a short and direct response. 0.88. What is the ratio of the Trade (in US$) of North America in 1963 to that in 1968?
Your response must be concise. 0.56. What is the ratio of the Trade (in US$) of Malawi in 1963 to that in 1968?
Provide a succinct answer. 0.75. What is the ratio of the Trade (in US$) of Togo in 1963 to that in 1968?
Your answer should be compact. 0.61. What is the ratio of the Trade (in US$) in Uruguay in 1963 to that in 1968?
Offer a terse response. 0.95. What is the ratio of the Trade (in US$) in North America in 1963 to that in 1969?
Provide a short and direct response. 0.51. What is the ratio of the Trade (in US$) of Malawi in 1963 to that in 1969?
Your response must be concise. 0.68. What is the ratio of the Trade (in US$) of Togo in 1963 to that in 1969?
Provide a succinct answer. 0.49. What is the ratio of the Trade (in US$) of Uruguay in 1963 to that in 1969?
Ensure brevity in your answer.  0.76. What is the ratio of the Trade (in US$) in North America in 1963 to that in 1970?
Give a very brief answer. 0.47. What is the ratio of the Trade (in US$) in Malawi in 1963 to that in 1970?
Your answer should be compact. 0.63. What is the ratio of the Trade (in US$) of Togo in 1963 to that in 1970?
Ensure brevity in your answer.  0.43. What is the ratio of the Trade (in US$) of Uruguay in 1963 to that in 1970?
Offer a very short reply. 0.57. What is the ratio of the Trade (in US$) of North America in 1964 to that in 1965?
Your response must be concise. 0.89. What is the ratio of the Trade (in US$) of Malawi in 1964 to that in 1965?
Your answer should be compact. 0.72. What is the ratio of the Trade (in US$) of Togo in 1964 to that in 1965?
Offer a terse response. 1.01. What is the ratio of the Trade (in US$) of Uruguay in 1964 to that in 1965?
Make the answer very short. 1.03. What is the ratio of the Trade (in US$) in North America in 1964 to that in 1966?
Your answer should be compact. 0.76. What is the ratio of the Trade (in US$) in Malawi in 1964 to that in 1966?
Ensure brevity in your answer.  0.57. What is the ratio of the Trade (in US$) of Togo in 1964 to that in 1966?
Ensure brevity in your answer.  0.88. What is the ratio of the Trade (in US$) of Uruguay in 1964 to that in 1966?
Your response must be concise. 1.08. What is the ratio of the Trade (in US$) of North America in 1964 to that in 1967?
Give a very brief answer. 0.71. What is the ratio of the Trade (in US$) of Malawi in 1964 to that in 1967?
Keep it short and to the point. 0.58. What is the ratio of the Trade (in US$) in Togo in 1964 to that in 1967?
Your response must be concise. 0.92. What is the ratio of the Trade (in US$) of Uruguay in 1964 to that in 1967?
Provide a succinct answer. 1.06. What is the ratio of the Trade (in US$) of North America in 1964 to that in 1968?
Your answer should be compact. 0.61. What is the ratio of the Trade (in US$) in Malawi in 1964 to that in 1968?
Offer a terse response. 0.57. What is the ratio of the Trade (in US$) of Togo in 1964 to that in 1968?
Your answer should be very brief. 0.84. What is the ratio of the Trade (in US$) of Uruguay in 1964 to that in 1968?
Your answer should be very brief. 1.15. What is the ratio of the Trade (in US$) of North America in 1964 to that in 1969?
Your response must be concise. 0.55. What is the ratio of the Trade (in US$) in Malawi in 1964 to that in 1969?
Ensure brevity in your answer.  0.52. What is the ratio of the Trade (in US$) in Togo in 1964 to that in 1969?
Your answer should be compact. 0.68. What is the ratio of the Trade (in US$) in Uruguay in 1964 to that in 1969?
Offer a very short reply. 0.92. What is the ratio of the Trade (in US$) in North America in 1964 to that in 1970?
Your response must be concise. 0.51. What is the ratio of the Trade (in US$) in Malawi in 1964 to that in 1970?
Offer a very short reply. 0.48. What is the ratio of the Trade (in US$) in Togo in 1964 to that in 1970?
Your answer should be very brief. 0.6. What is the ratio of the Trade (in US$) in Uruguay in 1964 to that in 1970?
Provide a succinct answer. 0.69. What is the ratio of the Trade (in US$) of North America in 1965 to that in 1966?
Provide a succinct answer. 0.85. What is the ratio of the Trade (in US$) of Malawi in 1965 to that in 1966?
Your answer should be compact. 0.79. What is the ratio of the Trade (in US$) in Togo in 1965 to that in 1966?
Offer a very short reply. 0.86. What is the ratio of the Trade (in US$) in Uruguay in 1965 to that in 1966?
Provide a short and direct response. 1.04. What is the ratio of the Trade (in US$) of North America in 1965 to that in 1967?
Your answer should be compact. 0.79. What is the ratio of the Trade (in US$) in Malawi in 1965 to that in 1967?
Give a very brief answer. 0.81. What is the ratio of the Trade (in US$) in Togo in 1965 to that in 1967?
Your answer should be compact. 0.91. What is the ratio of the Trade (in US$) of Uruguay in 1965 to that in 1967?
Offer a terse response. 1.03. What is the ratio of the Trade (in US$) of North America in 1965 to that in 1968?
Make the answer very short. 0.68. What is the ratio of the Trade (in US$) of Malawi in 1965 to that in 1968?
Your answer should be very brief. 0.79. What is the ratio of the Trade (in US$) of Togo in 1965 to that in 1968?
Ensure brevity in your answer.  0.83. What is the ratio of the Trade (in US$) in Uruguay in 1965 to that in 1968?
Ensure brevity in your answer.  1.12. What is the ratio of the Trade (in US$) in North America in 1965 to that in 1969?
Provide a short and direct response. 0.62. What is the ratio of the Trade (in US$) in Malawi in 1965 to that in 1969?
Ensure brevity in your answer.  0.72. What is the ratio of the Trade (in US$) of Togo in 1965 to that in 1969?
Provide a short and direct response. 0.67. What is the ratio of the Trade (in US$) of Uruguay in 1965 to that in 1969?
Offer a terse response. 0.89. What is the ratio of the Trade (in US$) of North America in 1965 to that in 1970?
Provide a succinct answer. 0.57. What is the ratio of the Trade (in US$) in Malawi in 1965 to that in 1970?
Your answer should be compact. 0.67. What is the ratio of the Trade (in US$) of Togo in 1965 to that in 1970?
Make the answer very short. 0.59. What is the ratio of the Trade (in US$) of Uruguay in 1965 to that in 1970?
Provide a succinct answer. 0.67. What is the ratio of the Trade (in US$) of North America in 1966 to that in 1967?
Provide a succinct answer. 0.93. What is the ratio of the Trade (in US$) in Malawi in 1966 to that in 1967?
Provide a succinct answer. 1.03. What is the ratio of the Trade (in US$) in Togo in 1966 to that in 1967?
Make the answer very short. 1.06. What is the ratio of the Trade (in US$) of Uruguay in 1966 to that in 1967?
Provide a succinct answer. 0.99. What is the ratio of the Trade (in US$) in North America in 1966 to that in 1968?
Give a very brief answer. 0.8. What is the ratio of the Trade (in US$) in Malawi in 1966 to that in 1968?
Give a very brief answer. 1.01. What is the ratio of the Trade (in US$) of Togo in 1966 to that in 1968?
Make the answer very short. 0.96. What is the ratio of the Trade (in US$) of Uruguay in 1966 to that in 1968?
Provide a short and direct response. 1.07. What is the ratio of the Trade (in US$) in North America in 1966 to that in 1969?
Give a very brief answer. 0.73. What is the ratio of the Trade (in US$) of Malawi in 1966 to that in 1969?
Make the answer very short. 0.92. What is the ratio of the Trade (in US$) in Togo in 1966 to that in 1969?
Your answer should be compact. 0.78. What is the ratio of the Trade (in US$) in Uruguay in 1966 to that in 1969?
Keep it short and to the point. 0.85. What is the ratio of the Trade (in US$) in North America in 1966 to that in 1970?
Make the answer very short. 0.67. What is the ratio of the Trade (in US$) of Malawi in 1966 to that in 1970?
Provide a succinct answer. 0.85. What is the ratio of the Trade (in US$) in Togo in 1966 to that in 1970?
Ensure brevity in your answer.  0.69. What is the ratio of the Trade (in US$) in Uruguay in 1966 to that in 1970?
Offer a terse response. 0.64. What is the ratio of the Trade (in US$) in North America in 1967 to that in 1968?
Give a very brief answer. 0.86. What is the ratio of the Trade (in US$) of Togo in 1967 to that in 1968?
Make the answer very short. 0.91. What is the ratio of the Trade (in US$) in Uruguay in 1967 to that in 1968?
Your answer should be very brief. 1.08. What is the ratio of the Trade (in US$) of North America in 1967 to that in 1969?
Your response must be concise. 0.78. What is the ratio of the Trade (in US$) of Malawi in 1967 to that in 1969?
Offer a very short reply. 0.89. What is the ratio of the Trade (in US$) of Togo in 1967 to that in 1969?
Offer a terse response. 0.74. What is the ratio of the Trade (in US$) of Uruguay in 1967 to that in 1969?
Provide a succinct answer. 0.87. What is the ratio of the Trade (in US$) in North America in 1967 to that in 1970?
Provide a succinct answer. 0.72. What is the ratio of the Trade (in US$) in Malawi in 1967 to that in 1970?
Provide a succinct answer. 0.83. What is the ratio of the Trade (in US$) in Togo in 1967 to that in 1970?
Keep it short and to the point. 0.65. What is the ratio of the Trade (in US$) of Uruguay in 1967 to that in 1970?
Your response must be concise. 0.65. What is the ratio of the Trade (in US$) of North America in 1968 to that in 1969?
Keep it short and to the point. 0.91. What is the ratio of the Trade (in US$) of Malawi in 1968 to that in 1969?
Make the answer very short. 0.91. What is the ratio of the Trade (in US$) of Togo in 1968 to that in 1969?
Your answer should be very brief. 0.81. What is the ratio of the Trade (in US$) of Uruguay in 1968 to that in 1969?
Give a very brief answer. 0.8. What is the ratio of the Trade (in US$) in North America in 1968 to that in 1970?
Give a very brief answer. 0.83. What is the ratio of the Trade (in US$) in Malawi in 1968 to that in 1970?
Keep it short and to the point. 0.84. What is the ratio of the Trade (in US$) in Togo in 1968 to that in 1970?
Make the answer very short. 0.71. What is the ratio of the Trade (in US$) of Uruguay in 1968 to that in 1970?
Offer a terse response. 0.6. What is the ratio of the Trade (in US$) of Malawi in 1969 to that in 1970?
Your response must be concise. 0.93. What is the ratio of the Trade (in US$) in Togo in 1969 to that in 1970?
Provide a short and direct response. 0.88. What is the ratio of the Trade (in US$) of Uruguay in 1969 to that in 1970?
Your response must be concise. 0.75. What is the difference between the highest and the second highest Trade (in US$) in North America?
Your answer should be compact. 5.83e+09. What is the difference between the highest and the second highest Trade (in US$) of Malawi?
Offer a terse response. 8.52e+06. What is the difference between the highest and the second highest Trade (in US$) of Togo?
Offer a very short reply. 1.19e+07. What is the difference between the highest and the second highest Trade (in US$) of Uruguay?
Your response must be concise. 8.19e+07. What is the difference between the highest and the lowest Trade (in US$) in North America?
Your response must be concise. 3.89e+1. What is the difference between the highest and the lowest Trade (in US$) of Malawi?
Your answer should be very brief. 5.87e+07. What is the difference between the highest and the lowest Trade (in US$) in Togo?
Make the answer very short. 5.58e+07. What is the difference between the highest and the lowest Trade (in US$) in Uruguay?
Your answer should be very brief. 1.40e+08. 